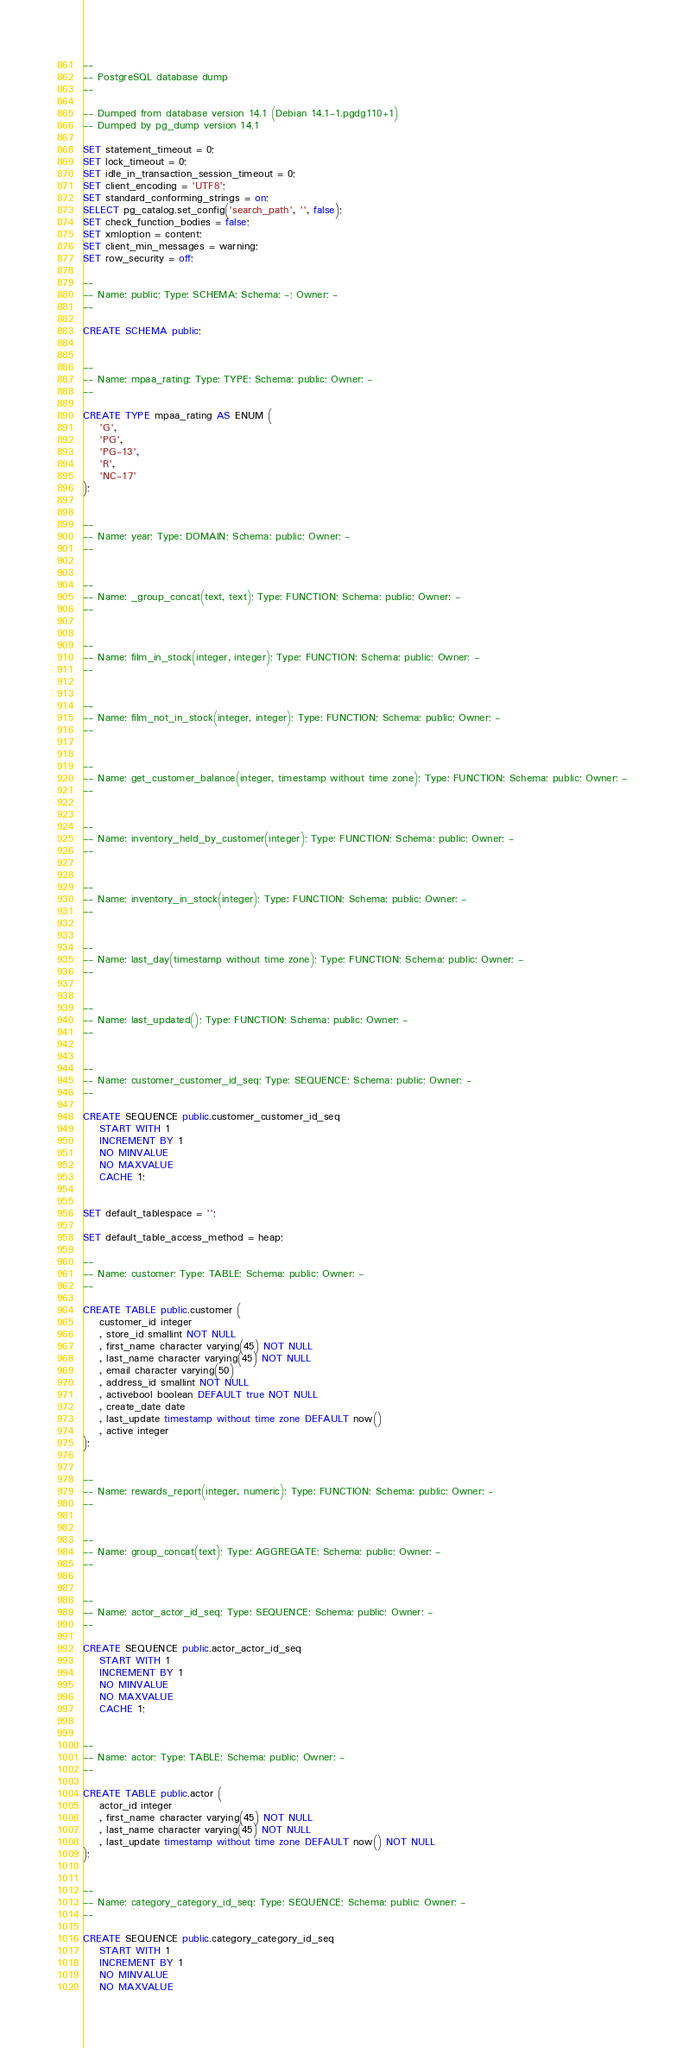<code> <loc_0><loc_0><loc_500><loc_500><_SQL_>--
-- PostgreSQL database dump
--

-- Dumped from database version 14.1 (Debian 14.1-1.pgdg110+1)
-- Dumped by pg_dump version 14.1

SET statement_timeout = 0;
SET lock_timeout = 0;
SET idle_in_transaction_session_timeout = 0;
SET client_encoding = 'UTF8';
SET standard_conforming_strings = on;
SELECT pg_catalog.set_config('search_path', '', false);
SET check_function_bodies = false;
SET xmloption = content;
SET client_min_messages = warning;
SET row_security = off;

--
-- Name: public; Type: SCHEMA; Schema: -; Owner: -
--

CREATE SCHEMA public;


--
-- Name: mpaa_rating; Type: TYPE; Schema: public; Owner: -
--

CREATE TYPE mpaa_rating AS ENUM (
    'G',
    'PG',
    'PG-13',
    'R',
    'NC-17'
);


--
-- Name: year; Type: DOMAIN; Schema: public; Owner: -
--


--
-- Name: _group_concat(text, text); Type: FUNCTION; Schema: public; Owner: -
--


--
-- Name: film_in_stock(integer, integer); Type: FUNCTION; Schema: public; Owner: -
--


--
-- Name: film_not_in_stock(integer, integer); Type: FUNCTION; Schema: public; Owner: -
--


--
-- Name: get_customer_balance(integer, timestamp without time zone); Type: FUNCTION; Schema: public; Owner: -
--


--
-- Name: inventory_held_by_customer(integer); Type: FUNCTION; Schema: public; Owner: -
--


--
-- Name: inventory_in_stock(integer); Type: FUNCTION; Schema: public; Owner: -
--


--
-- Name: last_day(timestamp without time zone); Type: FUNCTION; Schema: public; Owner: -
--


--
-- Name: last_updated(); Type: FUNCTION; Schema: public; Owner: -
--


--
-- Name: customer_customer_id_seq; Type: SEQUENCE; Schema: public; Owner: -
--

CREATE SEQUENCE public.customer_customer_id_seq
    START WITH 1
    INCREMENT BY 1
    NO MINVALUE
    NO MAXVALUE
    CACHE 1;


SET default_tablespace = '';

SET default_table_access_method = heap;

--
-- Name: customer; Type: TABLE; Schema: public; Owner: -
--

CREATE TABLE public.customer (
    customer_id integer
    , store_id smallint NOT NULL
    , first_name character varying(45) NOT NULL
    , last_name character varying(45) NOT NULL
    , email character varying(50)
    , address_id smallint NOT NULL
    , activebool boolean DEFAULT true NOT NULL
    , create_date date
    , last_update timestamp without time zone DEFAULT now()
    , active integer
);


--
-- Name: rewards_report(integer, numeric); Type: FUNCTION; Schema: public; Owner: -
--


--
-- Name: group_concat(text); Type: AGGREGATE; Schema: public; Owner: -
--


--
-- Name: actor_actor_id_seq; Type: SEQUENCE; Schema: public; Owner: -
--

CREATE SEQUENCE public.actor_actor_id_seq
    START WITH 1
    INCREMENT BY 1
    NO MINVALUE
    NO MAXVALUE
    CACHE 1;


--
-- Name: actor; Type: TABLE; Schema: public; Owner: -
--

CREATE TABLE public.actor (
    actor_id integer
    , first_name character varying(45) NOT NULL
    , last_name character varying(45) NOT NULL
    , last_update timestamp without time zone DEFAULT now() NOT NULL
);


--
-- Name: category_category_id_seq; Type: SEQUENCE; Schema: public; Owner: -
--

CREATE SEQUENCE public.category_category_id_seq
    START WITH 1
    INCREMENT BY 1
    NO MINVALUE
    NO MAXVALUE</code> 